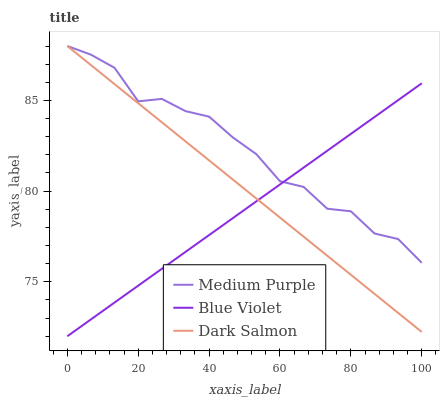Does Blue Violet have the minimum area under the curve?
Answer yes or no. Yes. Does Medium Purple have the maximum area under the curve?
Answer yes or no. Yes. Does Dark Salmon have the minimum area under the curve?
Answer yes or no. No. Does Dark Salmon have the maximum area under the curve?
Answer yes or no. No. Is Blue Violet the smoothest?
Answer yes or no. Yes. Is Medium Purple the roughest?
Answer yes or no. Yes. Is Dark Salmon the smoothest?
Answer yes or no. No. Is Dark Salmon the roughest?
Answer yes or no. No. Does Blue Violet have the lowest value?
Answer yes or no. Yes. Does Dark Salmon have the lowest value?
Answer yes or no. No. Does Dark Salmon have the highest value?
Answer yes or no. Yes. Does Blue Violet have the highest value?
Answer yes or no. No. Does Dark Salmon intersect Blue Violet?
Answer yes or no. Yes. Is Dark Salmon less than Blue Violet?
Answer yes or no. No. Is Dark Salmon greater than Blue Violet?
Answer yes or no. No. 